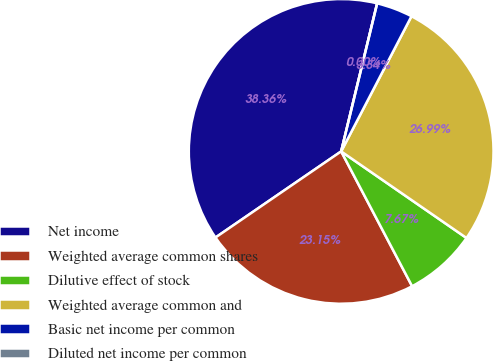Convert chart to OTSL. <chart><loc_0><loc_0><loc_500><loc_500><pie_chart><fcel>Net income<fcel>Weighted average common shares<fcel>Dilutive effect of stock<fcel>Weighted average common and<fcel>Basic net income per common<fcel>Diluted net income per common<nl><fcel>38.36%<fcel>23.15%<fcel>7.67%<fcel>26.99%<fcel>3.84%<fcel>0.0%<nl></chart> 